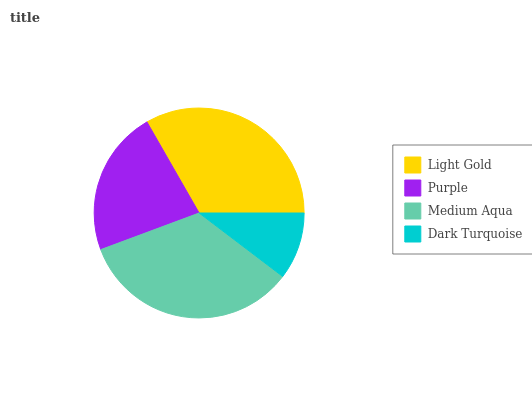Is Dark Turquoise the minimum?
Answer yes or no. Yes. Is Medium Aqua the maximum?
Answer yes or no. Yes. Is Purple the minimum?
Answer yes or no. No. Is Purple the maximum?
Answer yes or no. No. Is Light Gold greater than Purple?
Answer yes or no. Yes. Is Purple less than Light Gold?
Answer yes or no. Yes. Is Purple greater than Light Gold?
Answer yes or no. No. Is Light Gold less than Purple?
Answer yes or no. No. Is Light Gold the high median?
Answer yes or no. Yes. Is Purple the low median?
Answer yes or no. Yes. Is Purple the high median?
Answer yes or no. No. Is Light Gold the low median?
Answer yes or no. No. 